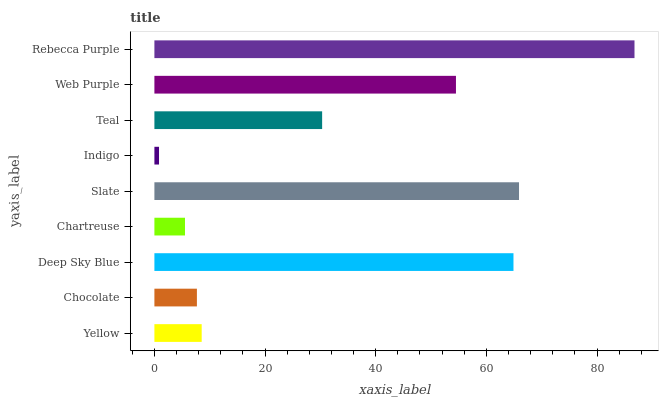Is Indigo the minimum?
Answer yes or no. Yes. Is Rebecca Purple the maximum?
Answer yes or no. Yes. Is Chocolate the minimum?
Answer yes or no. No. Is Chocolate the maximum?
Answer yes or no. No. Is Yellow greater than Chocolate?
Answer yes or no. Yes. Is Chocolate less than Yellow?
Answer yes or no. Yes. Is Chocolate greater than Yellow?
Answer yes or no. No. Is Yellow less than Chocolate?
Answer yes or no. No. Is Teal the high median?
Answer yes or no. Yes. Is Teal the low median?
Answer yes or no. Yes. Is Web Purple the high median?
Answer yes or no. No. Is Yellow the low median?
Answer yes or no. No. 